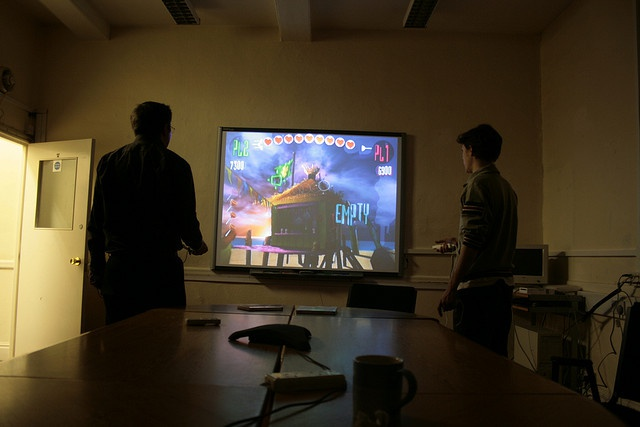Describe the objects in this image and their specific colors. I can see dining table in black, olive, and gray tones, tv in black, gray, lightblue, and lavender tones, people in black, olive, and gray tones, people in black and gray tones, and cup in black tones in this image. 